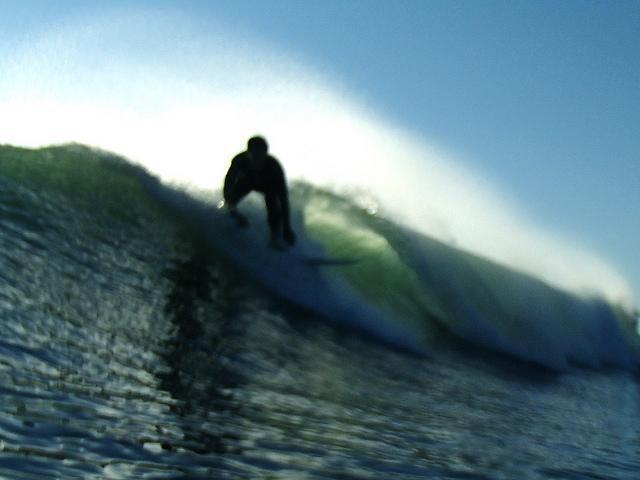How many boats do you see?
Give a very brief answer. 0. 